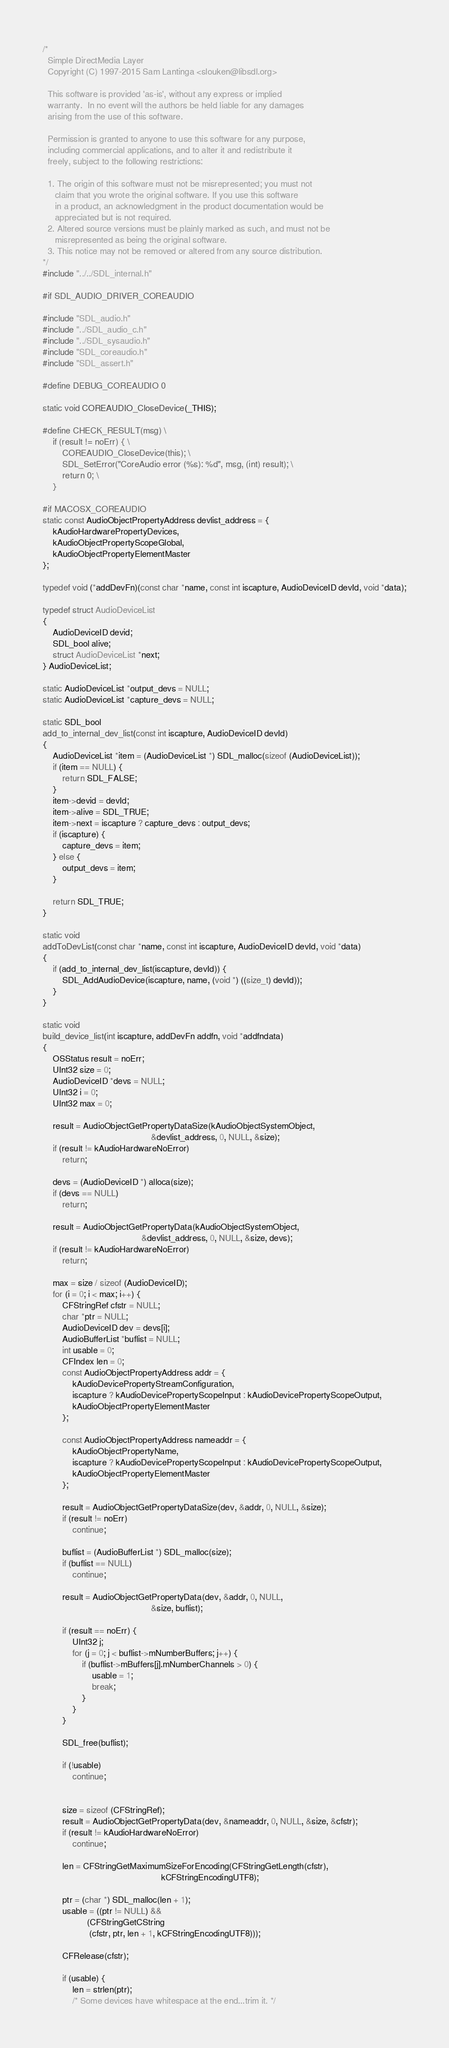Convert code to text. <code><loc_0><loc_0><loc_500><loc_500><_C_>/*
  Simple DirectMedia Layer
  Copyright (C) 1997-2015 Sam Lantinga <slouken@libsdl.org>

  This software is provided 'as-is', without any express or implied
  warranty.  In no event will the authors be held liable for any damages
  arising from the use of this software.

  Permission is granted to anyone to use this software for any purpose,
  including commercial applications, and to alter it and redistribute it
  freely, subject to the following restrictions:

  1. The origin of this software must not be misrepresented; you must not
     claim that you wrote the original software. If you use this software
     in a product, an acknowledgment in the product documentation would be
     appreciated but is not required.
  2. Altered source versions must be plainly marked as such, and must not be
     misrepresented as being the original software.
  3. This notice may not be removed or altered from any source distribution.
*/
#include "../../SDL_internal.h"

#if SDL_AUDIO_DRIVER_COREAUDIO

#include "SDL_audio.h"
#include "../SDL_audio_c.h"
#include "../SDL_sysaudio.h"
#include "SDL_coreaudio.h"
#include "SDL_assert.h"

#define DEBUG_COREAUDIO 0

static void COREAUDIO_CloseDevice(_THIS);

#define CHECK_RESULT(msg) \
    if (result != noErr) { \
        COREAUDIO_CloseDevice(this); \
        SDL_SetError("CoreAudio error (%s): %d", msg, (int) result); \
        return 0; \
    }

#if MACOSX_COREAUDIO
static const AudioObjectPropertyAddress devlist_address = {
    kAudioHardwarePropertyDevices,
    kAudioObjectPropertyScopeGlobal,
    kAudioObjectPropertyElementMaster
};

typedef void (*addDevFn)(const char *name, const int iscapture, AudioDeviceID devId, void *data);

typedef struct AudioDeviceList
{
    AudioDeviceID devid;
    SDL_bool alive;
    struct AudioDeviceList *next;
} AudioDeviceList;

static AudioDeviceList *output_devs = NULL;
static AudioDeviceList *capture_devs = NULL;

static SDL_bool
add_to_internal_dev_list(const int iscapture, AudioDeviceID devId)
{
    AudioDeviceList *item = (AudioDeviceList *) SDL_malloc(sizeof (AudioDeviceList));
    if (item == NULL) {
        return SDL_FALSE;
    }
    item->devid = devId;
    item->alive = SDL_TRUE;
    item->next = iscapture ? capture_devs : output_devs;
    if (iscapture) {
        capture_devs = item;
    } else {
        output_devs = item;
    }

    return SDL_TRUE;
}

static void
addToDevList(const char *name, const int iscapture, AudioDeviceID devId, void *data)
{
    if (add_to_internal_dev_list(iscapture, devId)) {
        SDL_AddAudioDevice(iscapture, name, (void *) ((size_t) devId));
    }
}

static void
build_device_list(int iscapture, addDevFn addfn, void *addfndata)
{
    OSStatus result = noErr;
    UInt32 size = 0;
    AudioDeviceID *devs = NULL;
    UInt32 i = 0;
    UInt32 max = 0;

    result = AudioObjectGetPropertyDataSize(kAudioObjectSystemObject,
                                            &devlist_address, 0, NULL, &size);
    if (result != kAudioHardwareNoError)
        return;

    devs = (AudioDeviceID *) alloca(size);
    if (devs == NULL)
        return;

    result = AudioObjectGetPropertyData(kAudioObjectSystemObject,
                                        &devlist_address, 0, NULL, &size, devs);
    if (result != kAudioHardwareNoError)
        return;

    max = size / sizeof (AudioDeviceID);
    for (i = 0; i < max; i++) {
        CFStringRef cfstr = NULL;
        char *ptr = NULL;
        AudioDeviceID dev = devs[i];
        AudioBufferList *buflist = NULL;
        int usable = 0;
        CFIndex len = 0;
        const AudioObjectPropertyAddress addr = {
            kAudioDevicePropertyStreamConfiguration,
            iscapture ? kAudioDevicePropertyScopeInput : kAudioDevicePropertyScopeOutput,
            kAudioObjectPropertyElementMaster
        };

        const AudioObjectPropertyAddress nameaddr = {
            kAudioObjectPropertyName,
            iscapture ? kAudioDevicePropertyScopeInput : kAudioDevicePropertyScopeOutput,
            kAudioObjectPropertyElementMaster
        };

        result = AudioObjectGetPropertyDataSize(dev, &addr, 0, NULL, &size);
        if (result != noErr)
            continue;

        buflist = (AudioBufferList *) SDL_malloc(size);
        if (buflist == NULL)
            continue;

        result = AudioObjectGetPropertyData(dev, &addr, 0, NULL,
                                            &size, buflist);

        if (result == noErr) {
            UInt32 j;
            for (j = 0; j < buflist->mNumberBuffers; j++) {
                if (buflist->mBuffers[j].mNumberChannels > 0) {
                    usable = 1;
                    break;
                }
            }
        }

        SDL_free(buflist);

        if (!usable)
            continue;


        size = sizeof (CFStringRef);
        result = AudioObjectGetPropertyData(dev, &nameaddr, 0, NULL, &size, &cfstr);
        if (result != kAudioHardwareNoError)
            continue;

        len = CFStringGetMaximumSizeForEncoding(CFStringGetLength(cfstr),
                                                kCFStringEncodingUTF8);

        ptr = (char *) SDL_malloc(len + 1);
        usable = ((ptr != NULL) &&
                  (CFStringGetCString
                   (cfstr, ptr, len + 1, kCFStringEncodingUTF8)));

        CFRelease(cfstr);

        if (usable) {
            len = strlen(ptr);
            /* Some devices have whitespace at the end...trim it. */</code> 